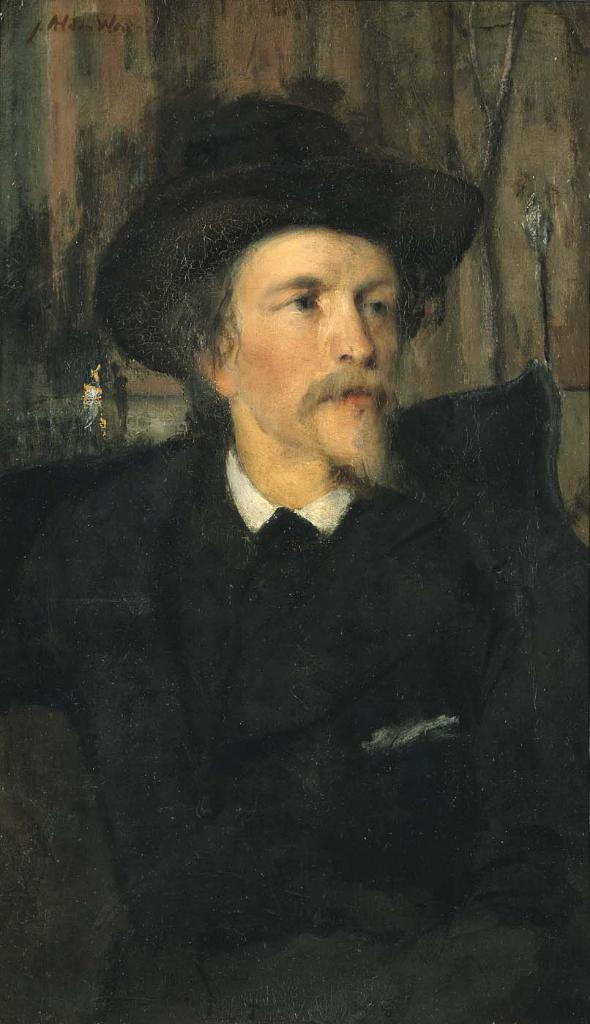What type of image is being shown? The image is a zoomed-in picture. What is the main subject of the image? There is a painting of a man in the image. What is the man in the painting doing? The man is sitting on a couch in the painting. What can be seen in the background of the painting? There is an object in the background of the painting. What else is visible in the image besides the painting? There is text visible in the image. What type of stick is visible in the image? There is no stick visible in the image. What type of oven can be seen in the image? There is no oven present in the image. 